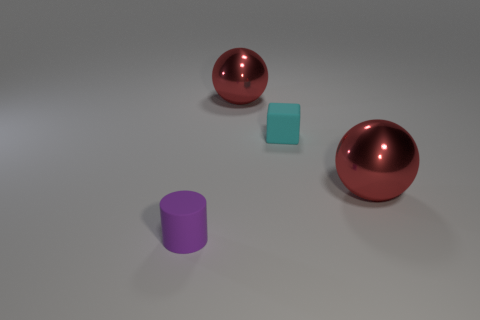Do the purple matte object and the shiny thing that is in front of the small cyan rubber object have the same shape?
Give a very brief answer. No. What number of things are either red things to the right of the cyan matte thing or cylinders that are to the left of the small cyan matte thing?
Keep it short and to the point. 2. Is the number of tiny purple objects that are in front of the purple rubber cylinder less than the number of cyan rubber blocks?
Provide a short and direct response. Yes. Is the block made of the same material as the purple cylinder that is in front of the small cyan object?
Offer a very short reply. Yes. What material is the purple cylinder?
Your response must be concise. Rubber. What material is the cylinder in front of the large red sphere behind the tiny object that is on the right side of the small purple matte object?
Give a very brief answer. Rubber. Is there any other thing that has the same shape as the small purple thing?
Offer a terse response. No. There is a object that is in front of the red shiny ball right of the cyan object; what is its color?
Ensure brevity in your answer.  Purple. How many large green metallic balls are there?
Offer a terse response. 0. How many shiny things are either spheres or tiny things?
Ensure brevity in your answer.  2. 